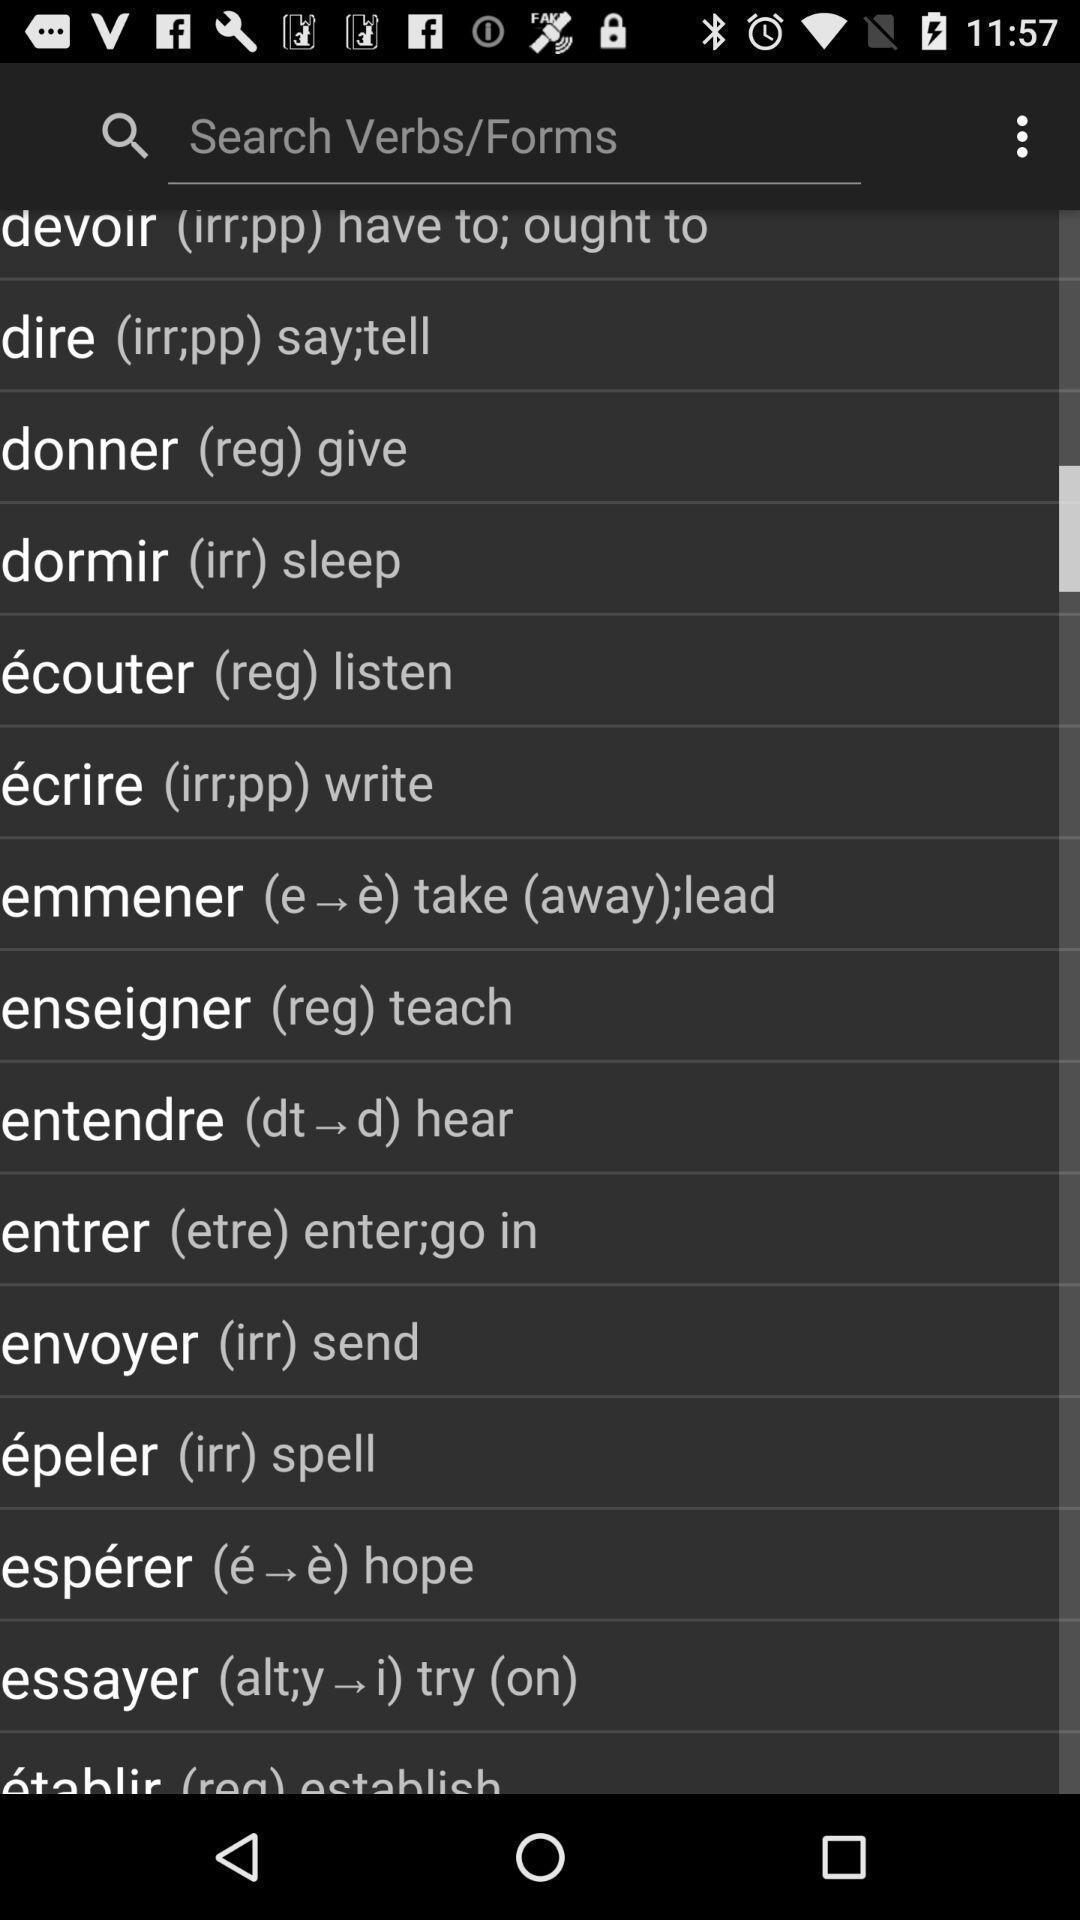Tell me about the visual elements in this screen capture. Search page. 